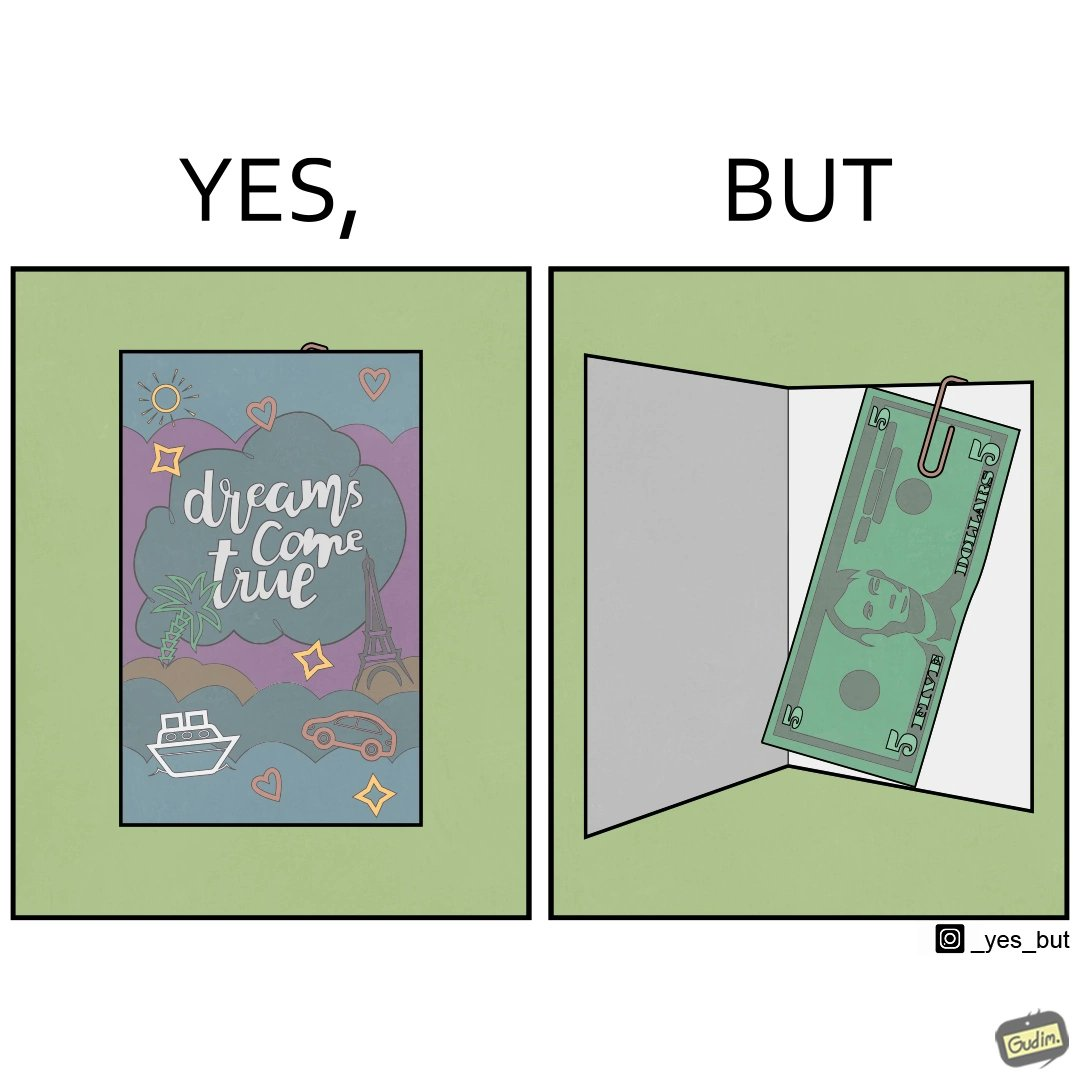Would you classify this image as satirical? Yes, this image is satirical. 